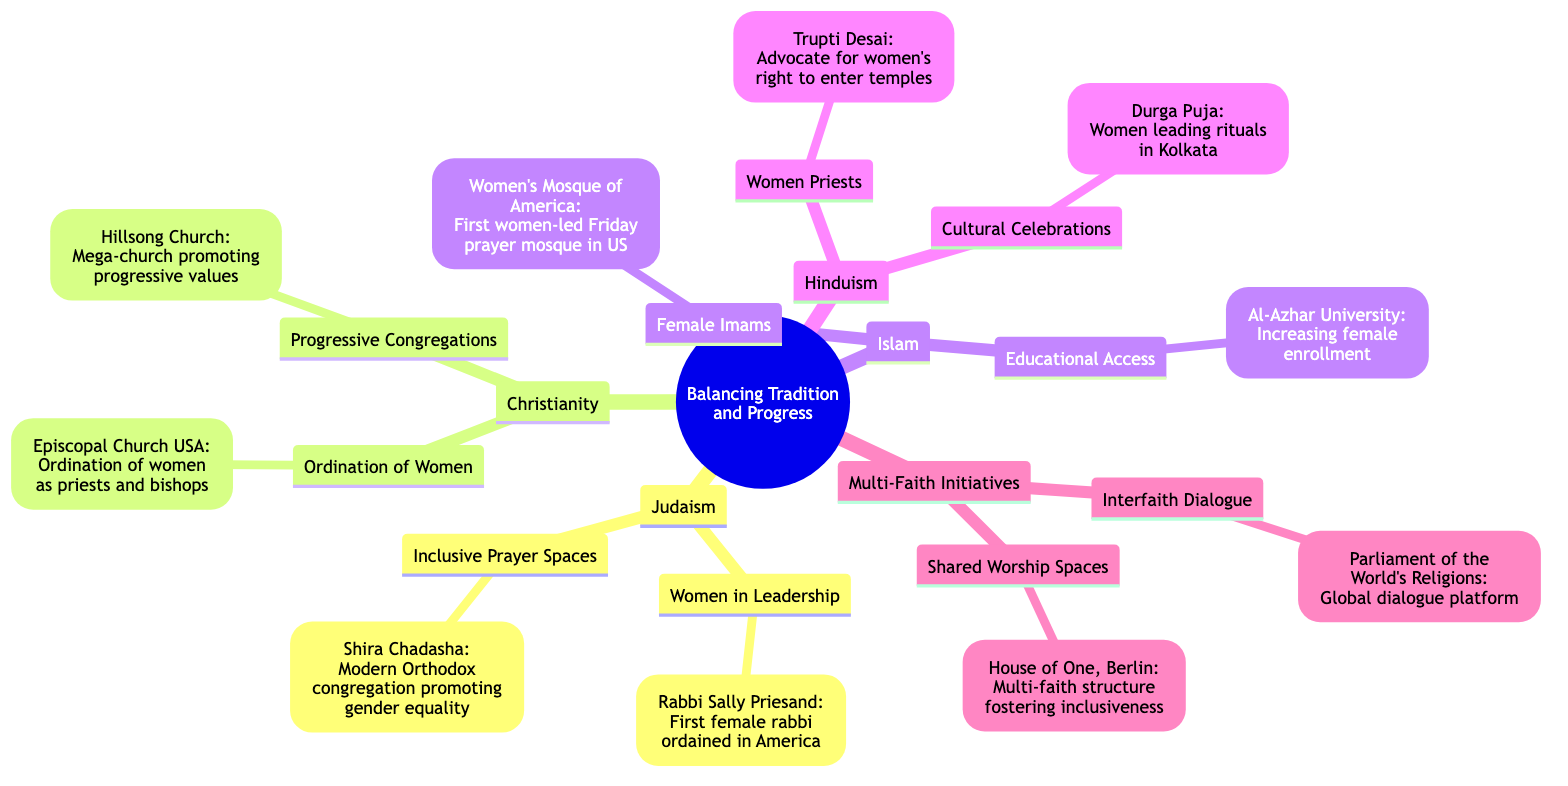What religion is associated with Rabbi Sally Priesand? The node under "Women in Leadership" points to "Rabbi Sally Priesand," which is categorized under "Judaism." Therefore, Rabbi Sally Priesand is associated with Judaism.
Answer: Judaism How many case studies are listed under Christianity? The "Christianity" node has two branches: "Ordination of Women" and "Progressive Congregations," each containing a case study. Counting these gives a total of two case studies.
Answer: 2 What is the case study mentioned for Women Priests? Under the "Women Priests" category in Hinduism, the case study listed is "Trupti Desai." This is the specific information provided in the diagram for that node.
Answer: Trupti Desai Which faith community has a case study about a women-led Friday prayer mosque? The case study listed under "Female Imams" in Islam refers to the "Women's Mosque of America," which indicates this faith community focuses on the leadership of women in religious practices.
Answer: Women's Mosque of America What is the common theme of the case studies in the Multi-Faith Initiatives category? The two case studies, "Interfaith Dialogue" and "Shared Worship Spaces," both emphasize promoting gender equality and inclusiveness across different faiths, indicating a focus on collaboration and unity in diversity.
Answer: Gender equality What event is associated with women leading rituals in Hinduism? The node under "Cultural Celebrations" points to "Durga Puja," where it specifically mentions the participation of women in leading rituals, providing a clear link to this event.
Answer: Durga Puja What characteristic is shared between the "Episcopal Church USA" and "Hillsong Church"? Both case studies under "Christianity" focus on the inclusion of women and progressive values within their practices, showcasing a shift from traditional values towards gender equality.
Answer: Inclusion of women Which multi-faith initiative is located in Berlin? The case study "House of One, Berlin" is listed under the "Shared Worship Spaces" node in the Multi-Faith Initiatives section, identifying it specifically with Berlin.
Answer: House of One, Berlin 